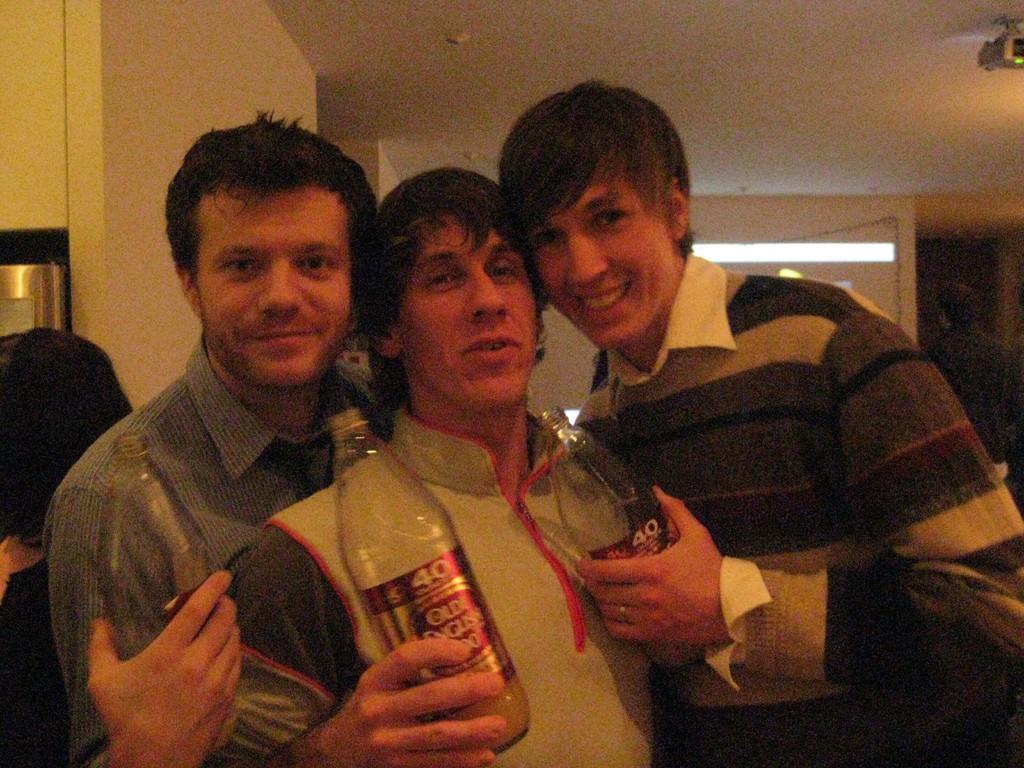How would you summarize this image in a sentence or two? Three people are standing and laughing, holding bottles in their hands. 